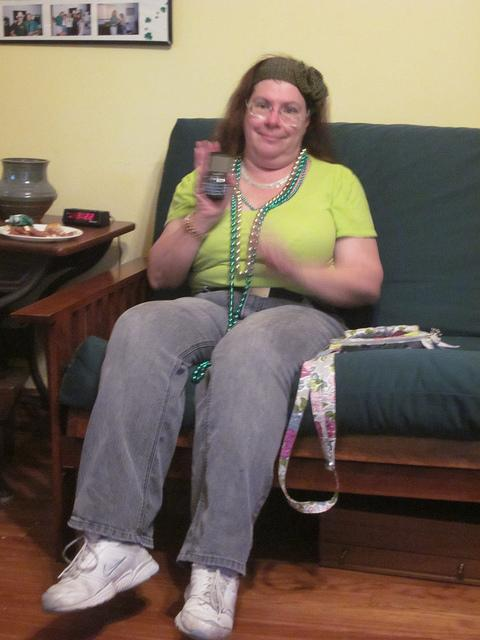What is the woman celebrating with her beads?

Choices:
A) easter
B) halloween
C) christmas
D) mardi gras mardi gras 